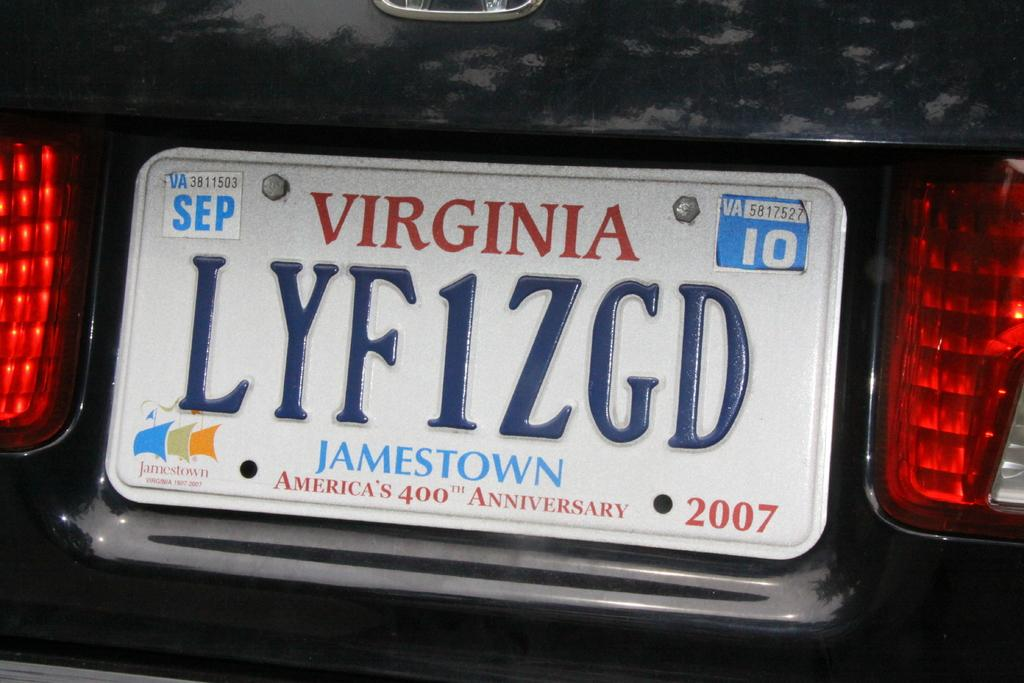<image>
Create a compact narrative representing the image presented. A car licence plate from the state of Virginia with a logo at the bottom that says Jamestown. 